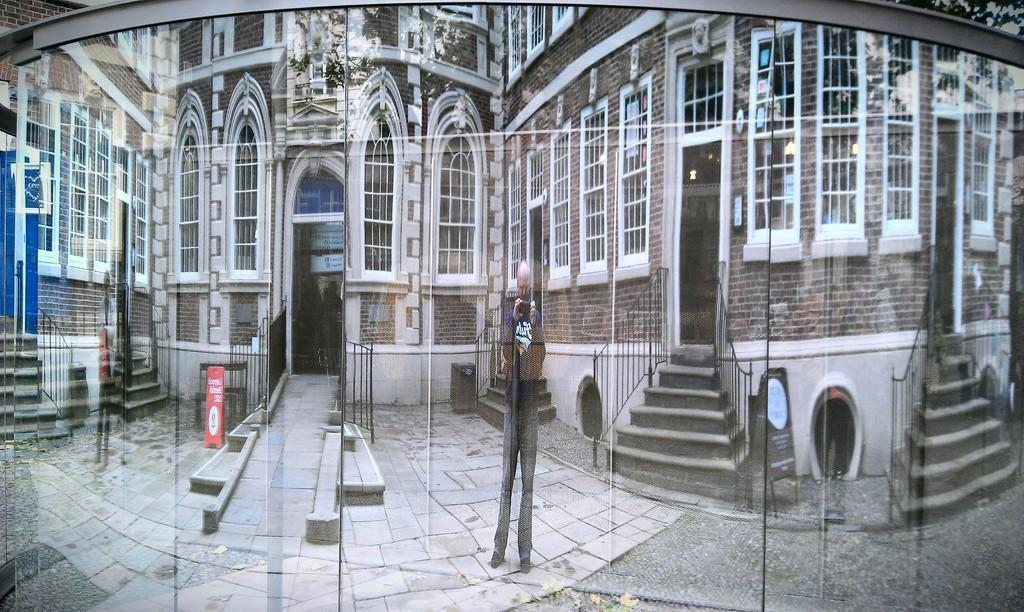Who is present in the image? There is a man in the image. What is the man holding in the image? The man is holding an object. What type of structure can be seen in the image? There is a building in the image. Is there any entrance visible in the image? Yes, there is a door in the image. What type of fog can be seen surrounding the man in the image? There is no fog present in the image; it is a clear scene. 